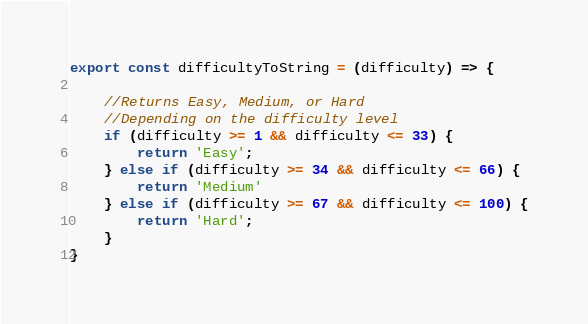Convert code to text. <code><loc_0><loc_0><loc_500><loc_500><_JavaScript_>export const difficultyToString = (difficulty) => {

    //Returns Easy, Medium, or Hard
    //Depending on the difficulty level
    if (difficulty >= 1 && difficulty <= 33) {
        return 'Easy';
    } else if (difficulty >= 34 && difficulty <= 66) {
        return 'Medium'
    } else if (difficulty >= 67 && difficulty <= 100) {
        return 'Hard';
    }
}</code> 